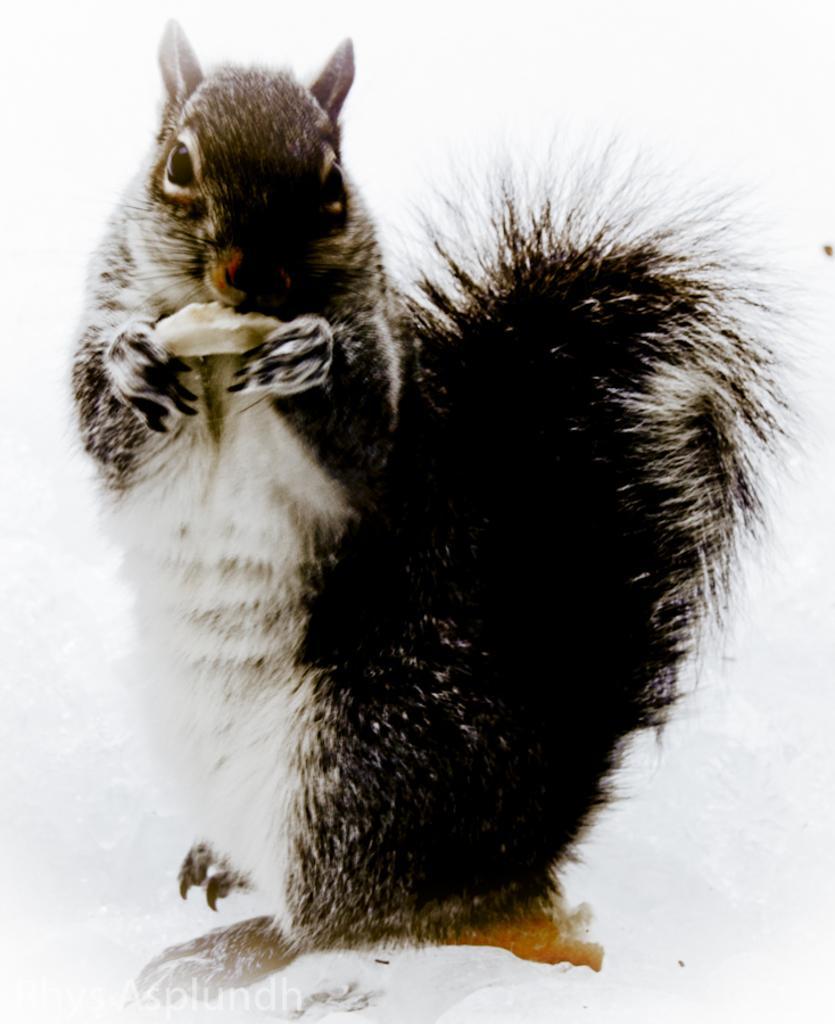Could you give a brief overview of what you see in this image? In this picture we can see the rabbit. He is holding some object. He is standing on the snow. On the bottom left corner there is a watermark. 